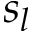<formula> <loc_0><loc_0><loc_500><loc_500>s _ { l }</formula> 